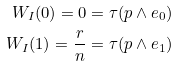<formula> <loc_0><loc_0><loc_500><loc_500>W _ { I } ( 0 ) = 0 = \tau ( p \wedge e _ { 0 } ) \\ W _ { I } ( 1 ) = \frac { r } { n } = \tau ( p \wedge e _ { 1 } )</formula> 